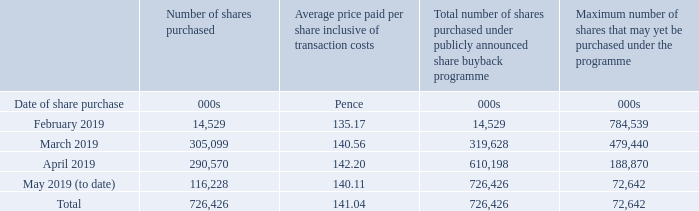Share buybacks
On 28 January 2019, Vodafone announced the commencement of a new irrevocable and non-discretionary share buy-back programme. The sole purpose of the programme was to reduce the issued share capital of Vodafone and thereby avoid any change in Vodafone’s issued share capital as a result of the maturing of the second tranche of the mandatory convertible bond (‘MCB’) in February 2019.
In order to satisfy the second tranche of the MCB, 799.1 of million shares were reissued from treasury shares on 25 February 2019 at a conversion price of £1.8021. This reflected the conversion price at issue (£2.1730) adjusted for the pound sterling equivalent of aggregate dividends paid from August 2016 to February 2019.
The share buyback programme started in February 2019 and is expected to complete by 20 May 2019. Details of the shares purchased under the programme, including those purchased under irrevocable instructions, are shown below.
How many shares were reissued from treasury shares to satisfy the second tranche of the MCB?
Answer scale should be: million. 799.1. What unit is the Average price paid per share inclusive of transaction costs expressed in? Pence. When is the share buyback programme expected to be completed? 20 may 2019. What is the percentage change between shares purchased in February and March 2019?
Answer scale should be: percent. (305,099-14,529)/14,529
Answer: 20. What is the percentage change between shares purchased in March and April 2019?
Answer scale should be: percent. (290,570-305,099)/305,099
Answer: -4.76. What percentage of total shares purchased is the April shares purchased?
Answer scale should be: percent. 290,570/726,426
Answer: 40. 